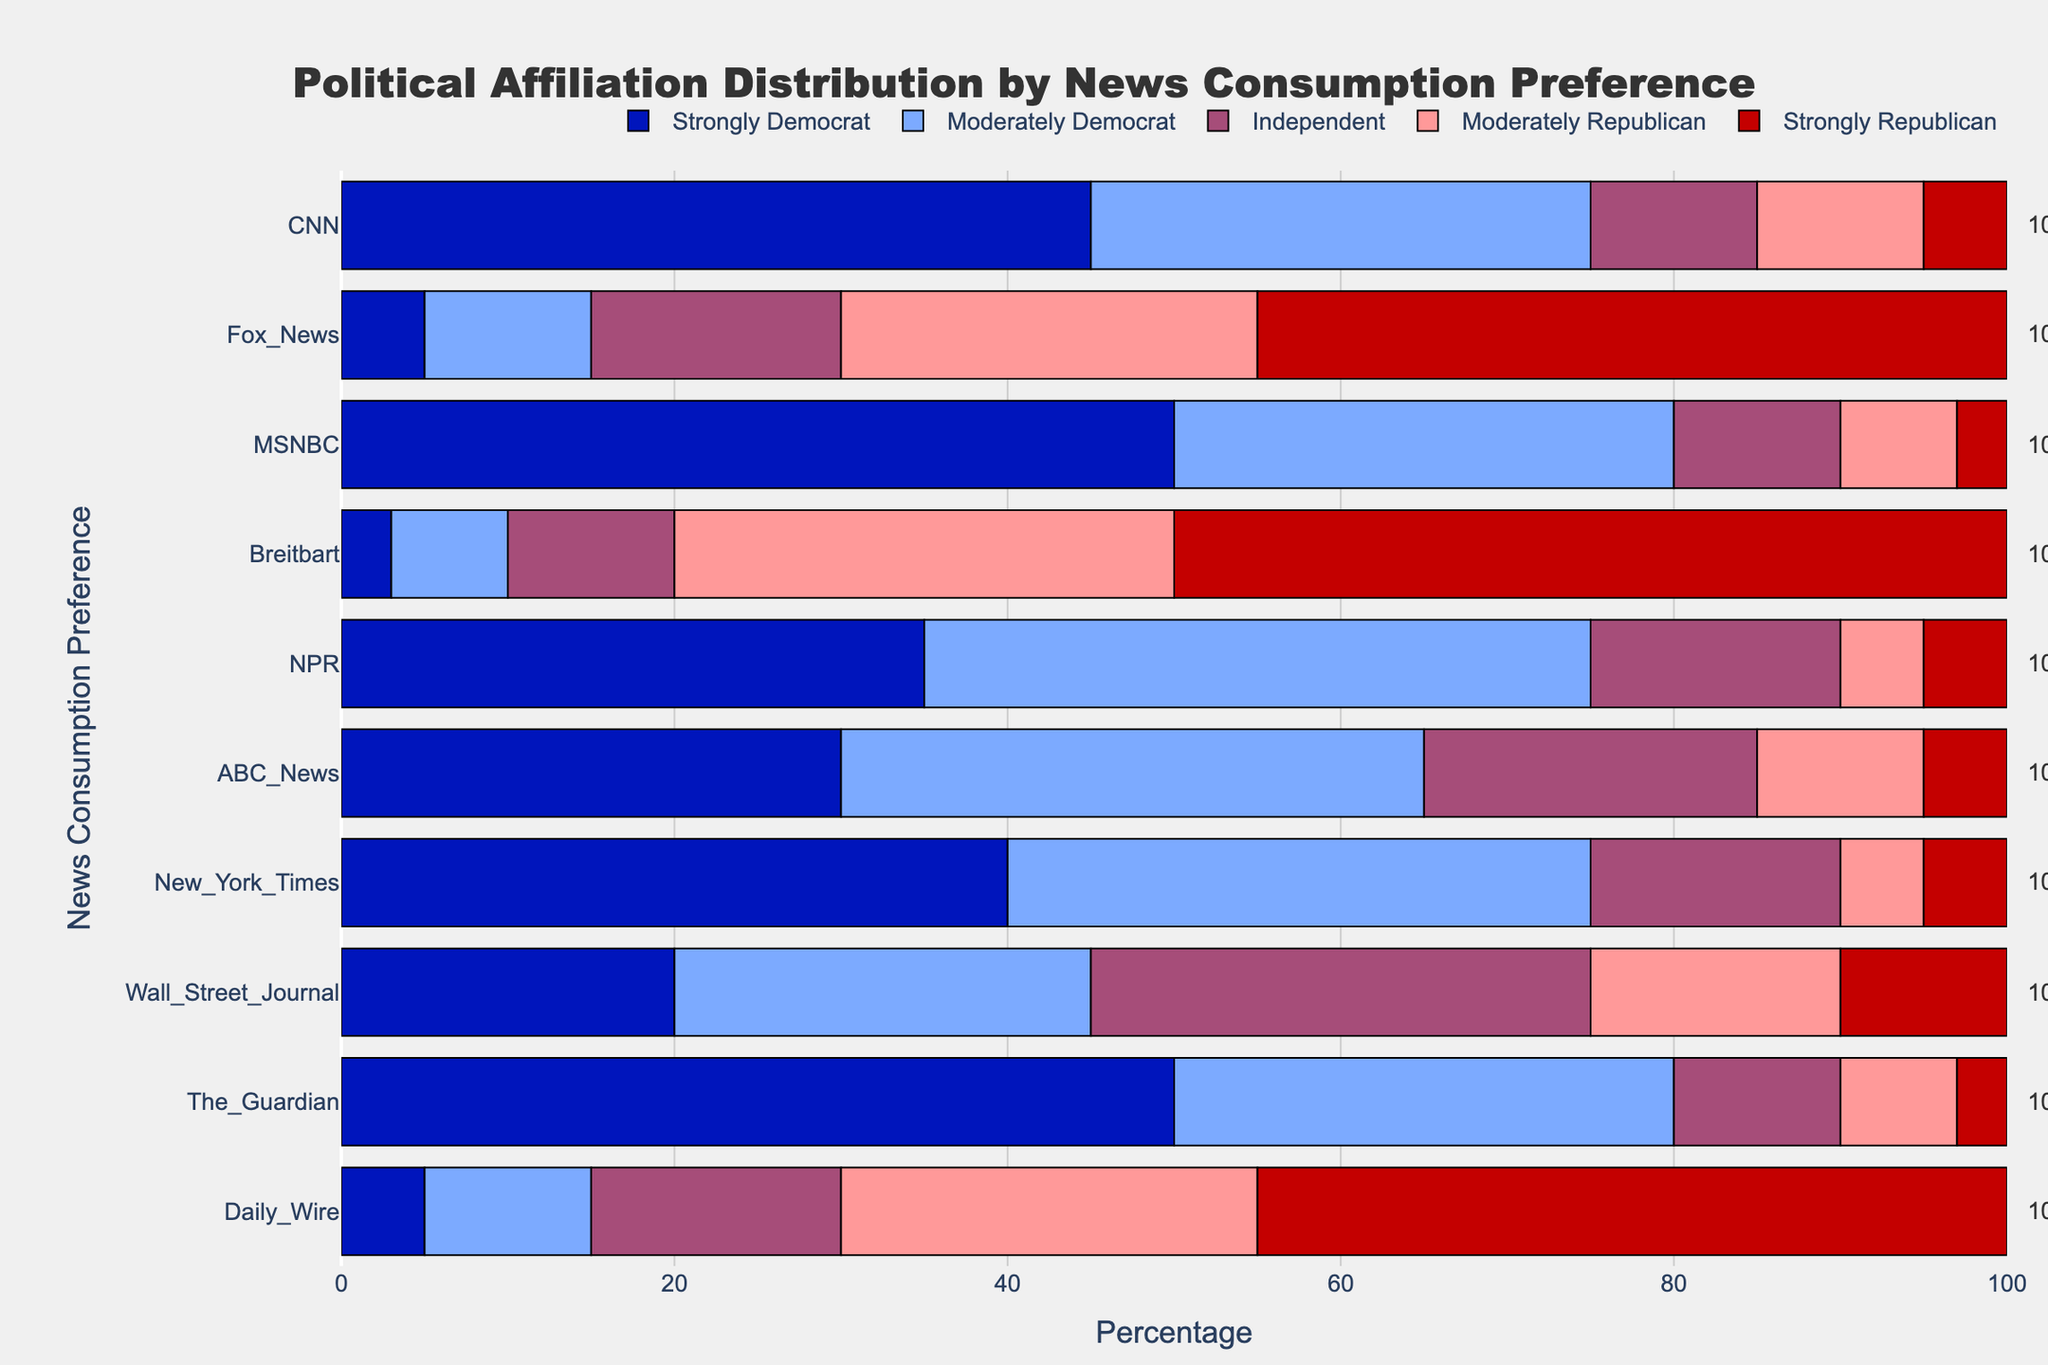What news source has the highest percentage of viewers who identify as Strongly Democrat? To answer this, look for the longest blue (Strongly Democrat) bar in the chart. MSNBC has the longest blue bar at 50%.
Answer: MSNBC Which news source has the largest combined percentage of Strongly Republicans and Moderately Republicans? To determine this, sum the lengths of the Strongly Republican and Moderately Republican bars for each news source. Fox News and Daily Wire each have combined percentages of 45% + 25% = 70%.
Answer: Fox News and Daily Wire What is the sum of Independent viewers across all news sources? Sum the percentage values of the Independent viewers (purple bars) for all the news sources: 10 + 15 + 10 + 10 + 15 + 20 + 15 + 30 + 10 + 15 = 150%.
Answer: 150% Which news source has the smallest percentage of viewers who identify as Moderately Democrat? Find the shortest light blue (Moderately Democrat) bar in the chart. Breitbart has the shortest bar at 7%.
Answer: Breitbart Is the percentage of Strongly Democrat viewers for The Guardian higher, lower, or equal to the percentage of Strongly Republican viewers for Fox News? Compare the lengths of the Strongly Democrat bar for The Guardian and the Strongly Republican bar for Fox News. Both have a value of 50%.
Answer: Equal What is the difference in percentage points between Strongly Democrat viewers of CNN and MSNBC? Subtract the percentage of Strongly Democrat viewers of CNN (45%) from that of MSNBC (50%). 50% - 45% = 5%.
Answer: 5% Which news source has the largest percentage of Moderately Democrat viewers without being a left-leaning source? Examine news sources that are not predominantly left-leaning, but have a significant light blue (Moderately Democrat) bar. Wall Street Journal has the highest at 25%.
Answer: Wall Street Journal What is the percentage of Independent viewers for the news source with the highest percentage of Strongly Republicans? Identify the news source with the highest Strongly Republican percentage (Breitbart and Fox News at 50%) and check their Independent viewer percentage. Both have 10%.
Answer: 10% Among CNN, NPR, and New York Times, which source has the highest percentage of viewers identifying as Independent? Compare the percentages of Independent viewers (purple bars) for CNN (10%), NPR (15%), and New York Times (15%). NPR and New York Times share the highest percentage at 15%.
Answer: NPR and New York Times 